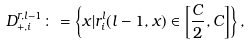Convert formula to latex. <formula><loc_0><loc_0><loc_500><loc_500>D ^ { r , l - 1 } _ { + , i } \colon = \left \{ x | r ^ { l } _ { i } ( l - 1 , x ) \in \left [ \frac { C } { 2 } , C \right ] \right \} ,</formula> 